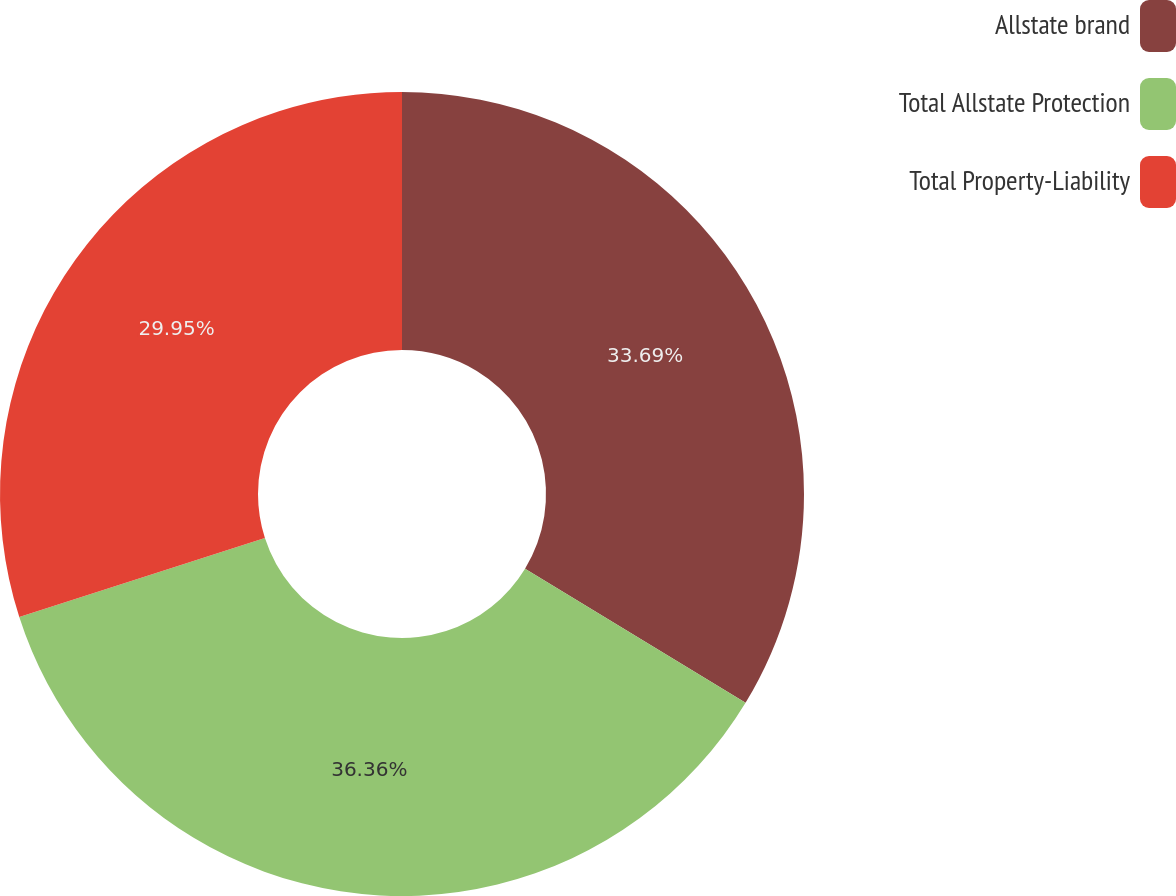Convert chart to OTSL. <chart><loc_0><loc_0><loc_500><loc_500><pie_chart><fcel>Allstate brand<fcel>Total Allstate Protection<fcel>Total Property-Liability<nl><fcel>33.69%<fcel>36.36%<fcel>29.95%<nl></chart> 